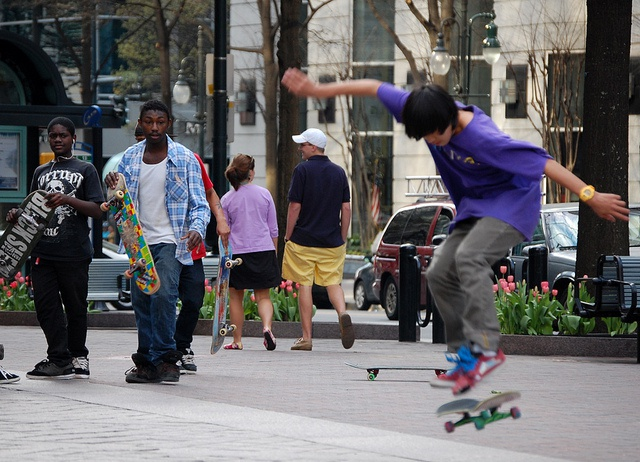Describe the objects in this image and their specific colors. I can see people in black, gray, navy, and brown tones, people in black, gray, darkgray, and lightgray tones, people in black, darkgray, and navy tones, people in black, brown, tan, and gray tones, and people in black, violet, and darkgray tones in this image. 